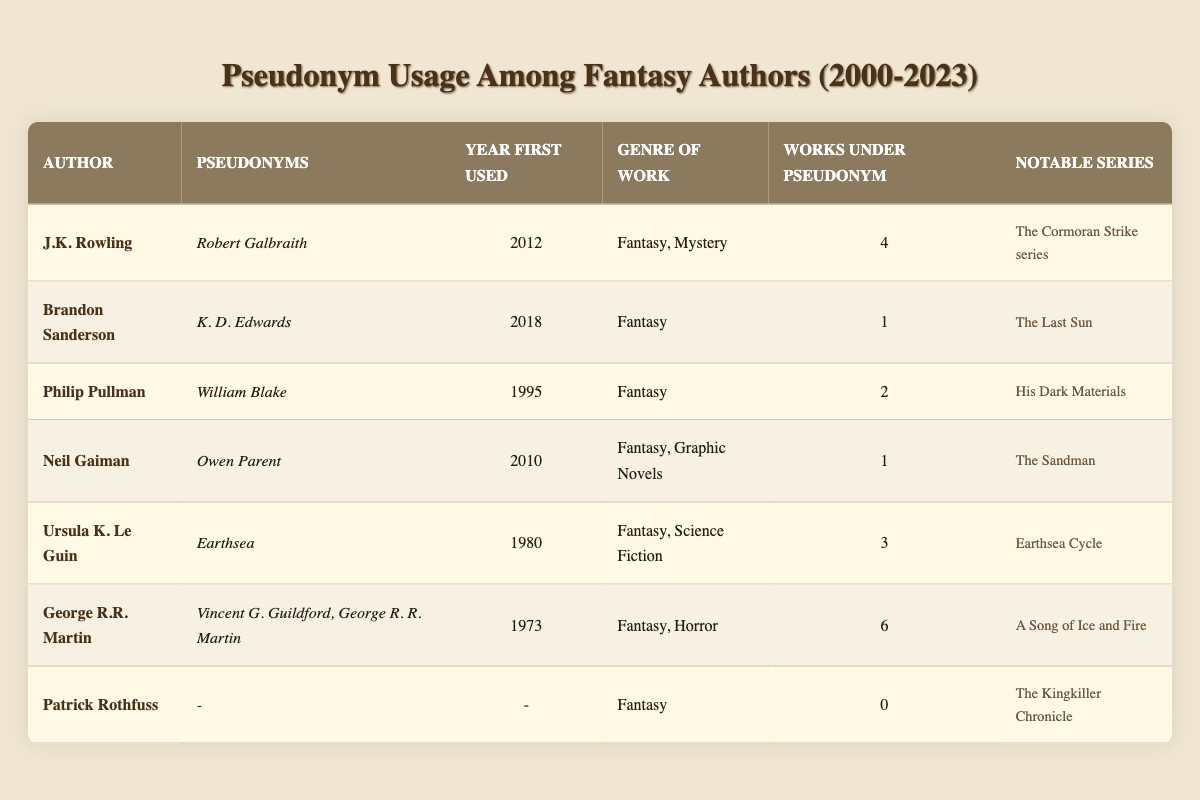What pseudonym did J.K. Rowling use? According to the table, J.K. Rowling used the pseudonym "Robert Galbraith."
Answer: Robert Galbraith Which author has the most works published under a pseudonym? By analyzing the "Works Under Pseudonym" column, George R.R. Martin has the most with 6 works published.
Answer: George R.R. Martin Did Patrick Rothfuss ever use a pseudonym for his literary work? In the table, under the row for Patrick Rothfuss, it shows that he has not used any pseudonyms, as indicated by the count of 0 works under pseudonym.
Answer: No In which year did Neil Gaiman first use his pseudonym? The table indicates that Neil Gaiman first used the pseudonym "Owen Parent" in the year 2010, which is stated clearly in the relevant column.
Answer: 2010 What is the total number of works published under pseudonyms by all authors listed? To find the total, we sum the "Works Under Pseudonym" column: 4 (J.K. Rowling) + 1 (Brandon Sanderson) + 2 (Philip Pullman) + 1 (Neil Gaiman) + 3 (Ursula K. Le Guin) + 6 (George R.R. Martin) + 0 (Patrick Rothfuss) = 17.
Answer: 17 Which author first used their pseudonym in 2012? By looking at the "Year First Used" column, it is identified that J.K. Rowling is the author who started using a pseudonym in the year 2012.
Answer: J.K. Rowling List the notable series associated with the pseudonym used by George R.R. Martin. The table specifies the notable series linked with the pseudonym used by George R.R. Martin as "A Song of Ice and Fire."
Answer: A Song of Ice and Fire How many authors have not used a pseudonym at all? By reviewing the "Works Under Pseudonym" column, we see that only Patrick Rothfuss has 0 works under pseudonym, indicating that he is the only author among the seven listed who has not used a pseudonym.
Answer: 1 What genre of work is primarily associated with Brandon Sanderson? The table indicates that Brandon Sanderson's primary genre is Fantasy, as specified in the "Genre of Work" column.
Answer: Fantasy 